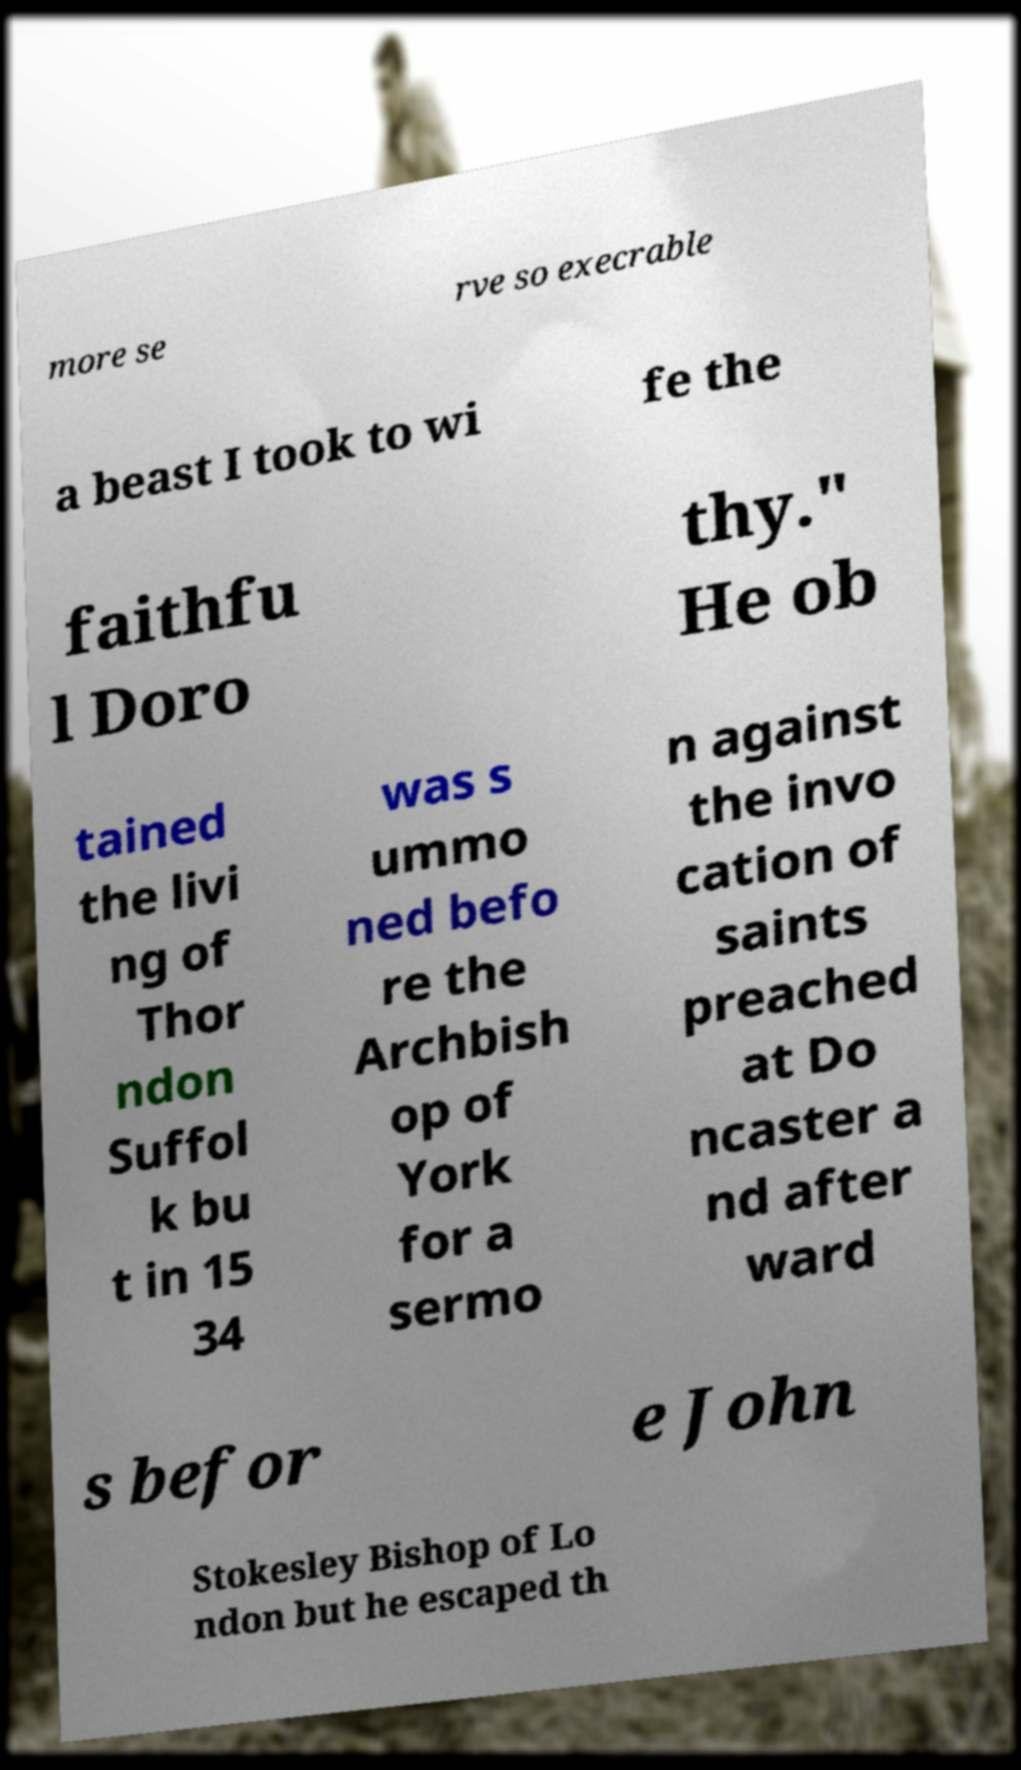What messages or text are displayed in this image? I need them in a readable, typed format. more se rve so execrable a beast I took to wi fe the faithfu l Doro thy." He ob tained the livi ng of Thor ndon Suffol k bu t in 15 34 was s ummo ned befo re the Archbish op of York for a sermo n against the invo cation of saints preached at Do ncaster a nd after ward s befor e John Stokesley Bishop of Lo ndon but he escaped th 